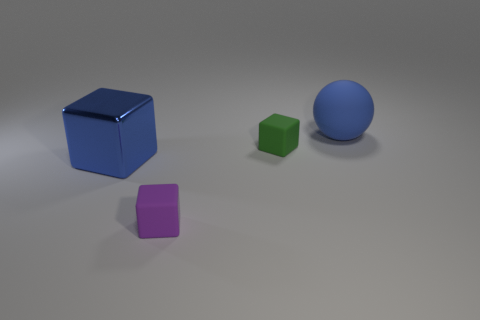Are there any other things that are made of the same material as the big block?
Offer a terse response. No. Is the number of rubber objects that are behind the large ball less than the number of large brown metal cylinders?
Your answer should be compact. No. Does the small purple rubber thing have the same shape as the small green object?
Provide a short and direct response. Yes. How big is the blue thing that is left of the blue matte object?
Make the answer very short. Large. The cube that is the same material as the small green thing is what size?
Make the answer very short. Small. Is the number of large blue cubes less than the number of small blue spheres?
Offer a terse response. No. There is a block that is the same size as the blue rubber ball; what is its material?
Provide a succinct answer. Metal. Is the number of large cubes greater than the number of matte blocks?
Your answer should be compact. No. What number of other things are there of the same color as the matte ball?
Give a very brief answer. 1. What number of things are in front of the big blue matte ball and on the right side of the purple rubber thing?
Your response must be concise. 1. 